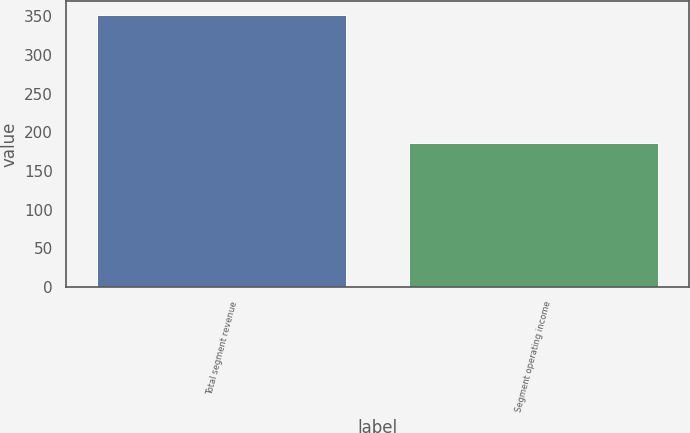Convert chart. <chart><loc_0><loc_0><loc_500><loc_500><bar_chart><fcel>Total segment revenue<fcel>Segment operating income<nl><fcel>352<fcel>186<nl></chart> 